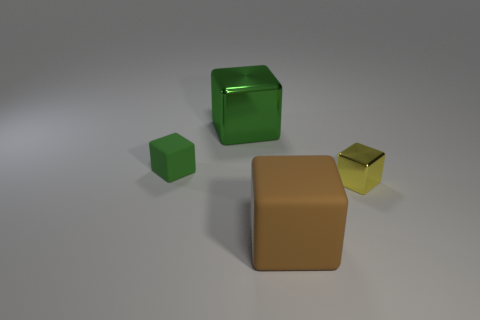Add 4 large green shiny things. How many objects exist? 8 Subtract all cyan blocks. Subtract all cyan balls. How many blocks are left? 4 Subtract all tiny green cubes. Subtract all big cyan cubes. How many objects are left? 3 Add 2 big brown matte things. How many big brown matte things are left? 3 Add 4 large green metallic cubes. How many large green metallic cubes exist? 5 Subtract 0 brown cylinders. How many objects are left? 4 